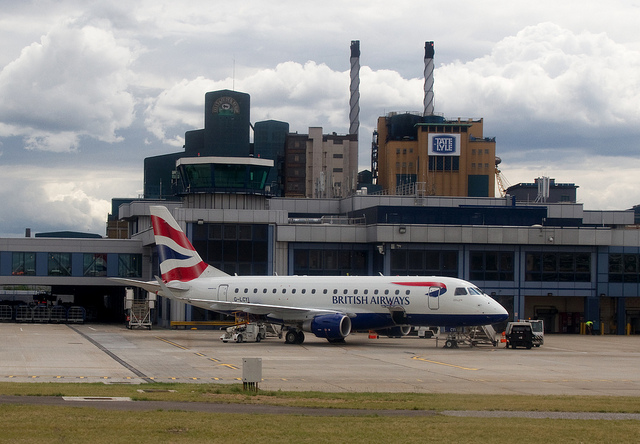Describe the weather conditions visible in the image. The weather appears to be partly cloudy with scattered clouds in the sky. There is no sign of precipitation, and the visibility seems good. 